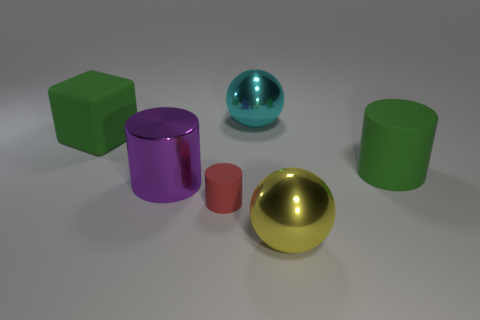Are there an equal number of big purple metallic cylinders that are to the left of the green matte cylinder and large green rubber cylinders to the right of the purple metal object?
Make the answer very short. Yes. What is the color of the rubber cylinder that is the same size as the purple shiny object?
Your answer should be very brief. Green. What number of small things are either green metallic cubes or cyan spheres?
Make the answer very short. 0. What material is the thing that is both in front of the large rubber block and behind the large shiny cylinder?
Provide a short and direct response. Rubber. Is the shape of the large green thing that is behind the green matte cylinder the same as the big metallic object that is behind the large purple metal cylinder?
Your answer should be compact. No. There is a rubber object that is the same color as the block; what is its shape?
Provide a short and direct response. Cylinder. How many objects are cylinders to the right of the large yellow metallic ball or small purple metallic spheres?
Offer a terse response. 1. Is the red thing the same size as the cyan object?
Give a very brief answer. No. There is a object that is on the right side of the big yellow thing; what is its color?
Provide a succinct answer. Green. There is a ball that is made of the same material as the yellow thing; what is its size?
Offer a very short reply. Large. 